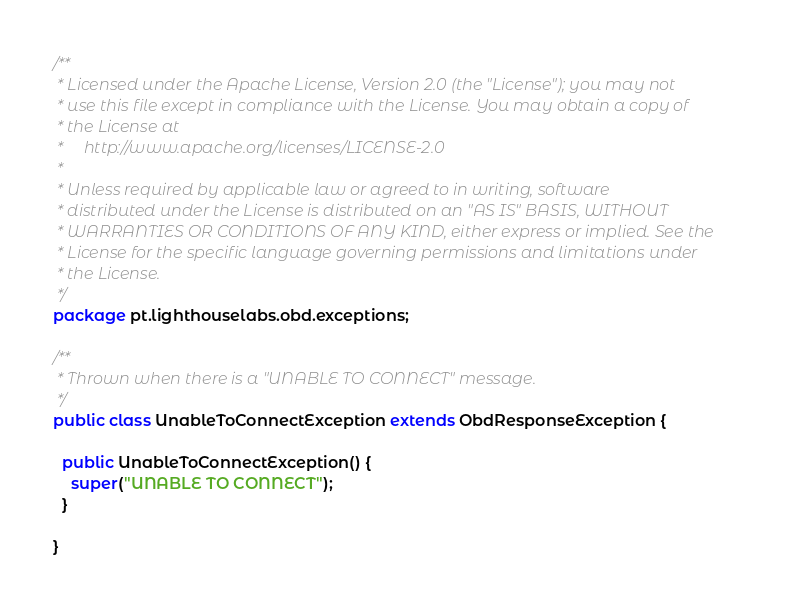Convert code to text. <code><loc_0><loc_0><loc_500><loc_500><_Java_>/**
 * Licensed under the Apache License, Version 2.0 (the "License"); you may not
 * use this file except in compliance with the License. You may obtain a copy of
 * the License at
 *     http://www.apache.org/licenses/LICENSE-2.0
 *
 * Unless required by applicable law or agreed to in writing, software
 * distributed under the License is distributed on an "AS IS" BASIS, WITHOUT
 * WARRANTIES OR CONDITIONS OF ANY KIND, either express or implied. See the
 * License for the specific language governing permissions and limitations under
 * the License.
 */
package pt.lighthouselabs.obd.exceptions;

/**
 * Thrown when there is a "UNABLE TO CONNECT" message.
 */
public class UnableToConnectException extends ObdResponseException {

  public UnableToConnectException() {
    super("UNABLE TO CONNECT");
  }

}
</code> 